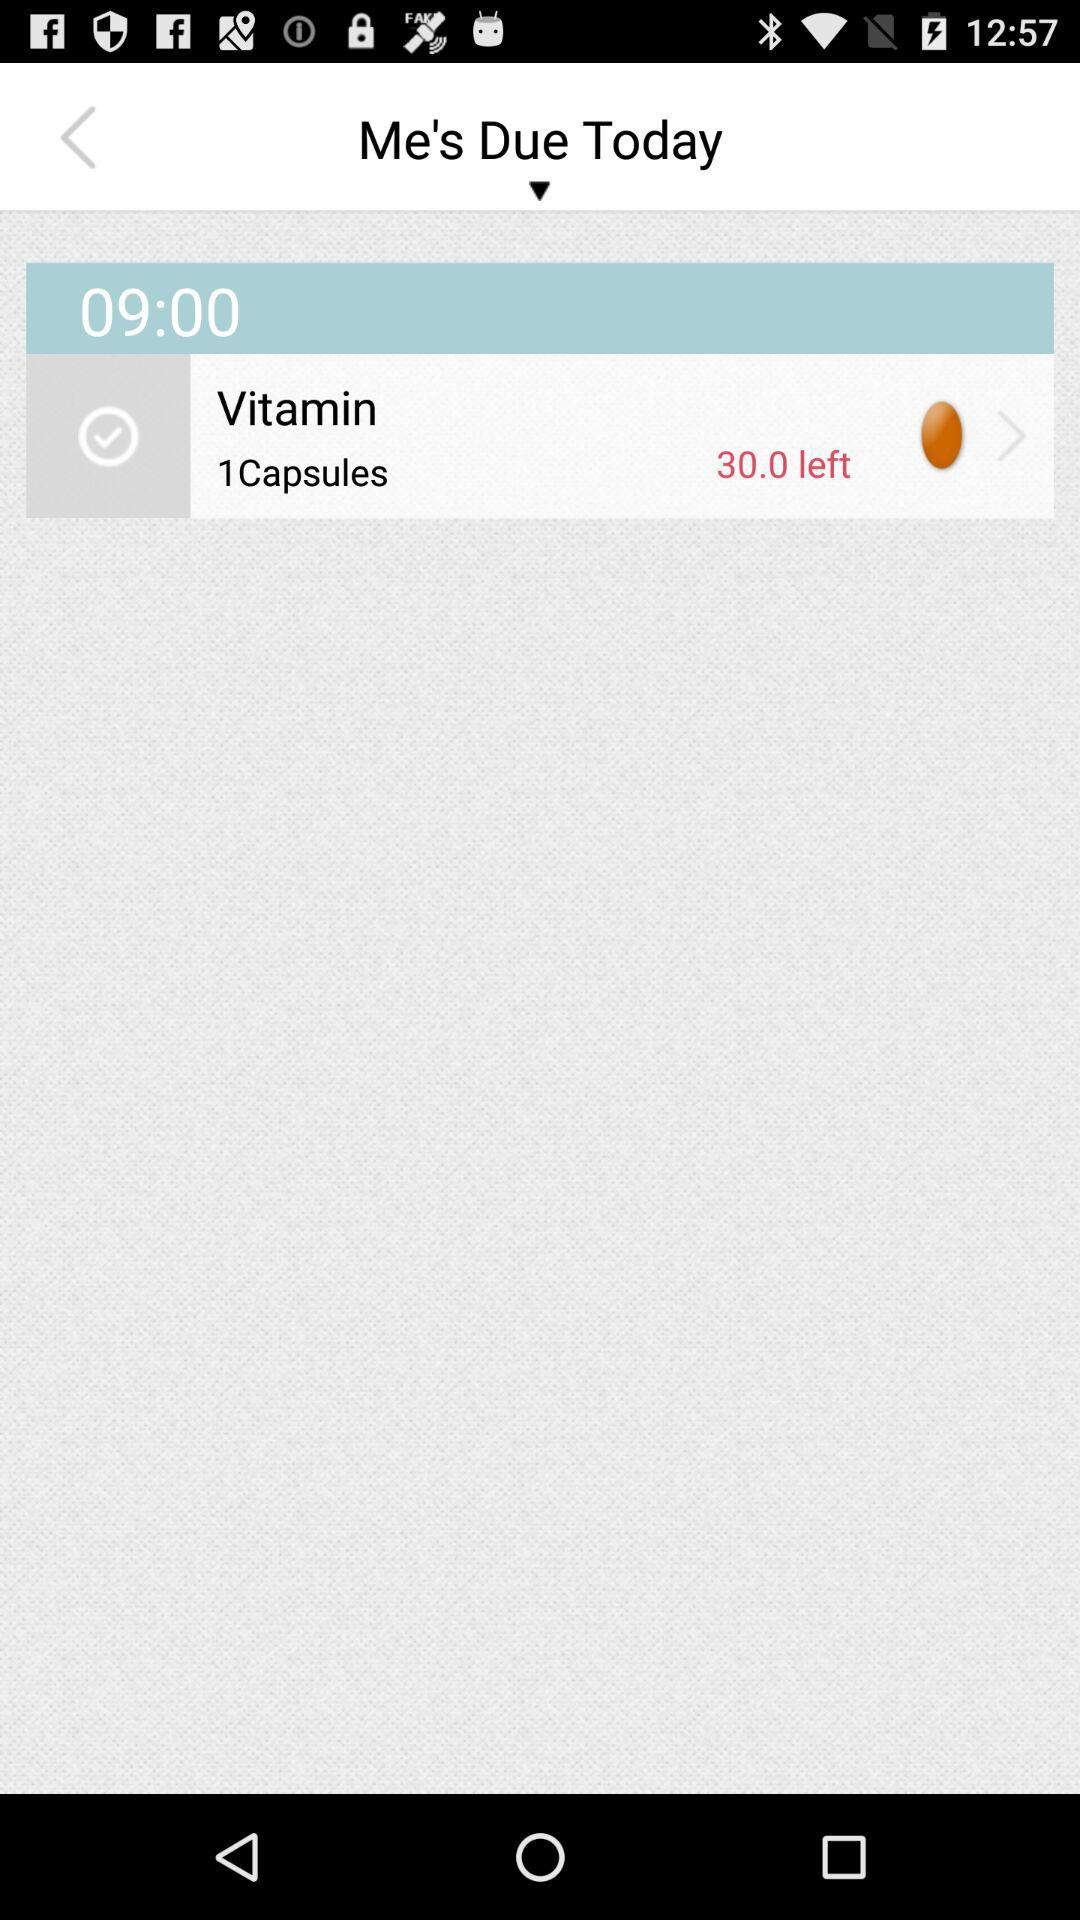How many capsules does the user need to take?
Answer the question using a single word or phrase. 1 